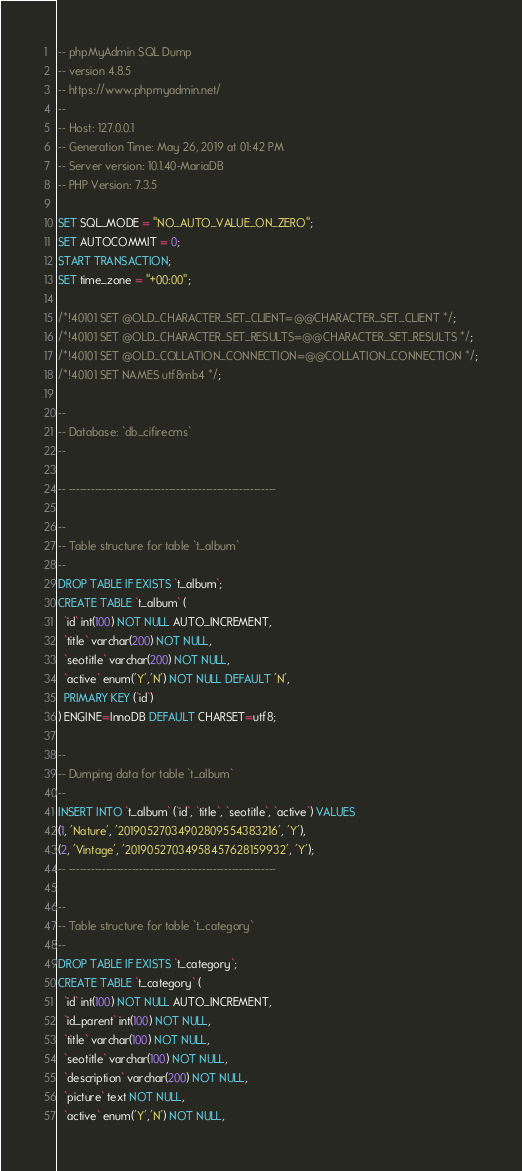Convert code to text. <code><loc_0><loc_0><loc_500><loc_500><_SQL_>-- phpMyAdmin SQL Dump
-- version 4.8.5
-- https://www.phpmyadmin.net/
--
-- Host: 127.0.0.1
-- Generation Time: May 26, 2019 at 01:42 PM
-- Server version: 10.1.40-MariaDB
-- PHP Version: 7.3.5

SET SQL_MODE = "NO_AUTO_VALUE_ON_ZERO";
SET AUTOCOMMIT = 0;
START TRANSACTION;
SET time_zone = "+00:00";

/*!40101 SET @OLD_CHARACTER_SET_CLIENT=@@CHARACTER_SET_CLIENT */;
/*!40101 SET @OLD_CHARACTER_SET_RESULTS=@@CHARACTER_SET_RESULTS */;
/*!40101 SET @OLD_COLLATION_CONNECTION=@@COLLATION_CONNECTION */;
/*!40101 SET NAMES utf8mb4 */;

--
-- Database: `db_cifirecms`
--

-- --------------------------------------------------------

--
-- Table structure for table `t_album`
--
DROP TABLE IF EXISTS `t_album`;
CREATE TABLE `t_album` (
  `id` int(100) NOT NULL AUTO_INCREMENT,
  `title` varchar(200) NOT NULL,
  `seotitle` varchar(200) NOT NULL,
  `active` enum('Y','N') NOT NULL DEFAULT 'N',
  PRIMARY KEY (`id`)
) ENGINE=InnoDB DEFAULT CHARSET=utf8;

--
-- Dumping data for table `t_album`
--
INSERT INTO `t_album` (`id`, `title`, `seotitle`, `active`) VALUES
(1, 'Nature', '20190527034902809554383216', 'Y'),
(2, 'Vintage', '20190527034958457628159932', 'Y');
-- --------------------------------------------------------

--
-- Table structure for table `t_category`
--
DROP TABLE IF EXISTS `t_category`;
CREATE TABLE `t_category` (
  `id` int(100) NOT NULL AUTO_INCREMENT,
  `id_parent` int(100) NOT NULL,
  `title` varchar(100) NOT NULL,
  `seotitle` varchar(100) NOT NULL,
  `description` varchar(200) NOT NULL,
  `picture` text NOT NULL,
  `active` enum('Y','N') NOT NULL,</code> 